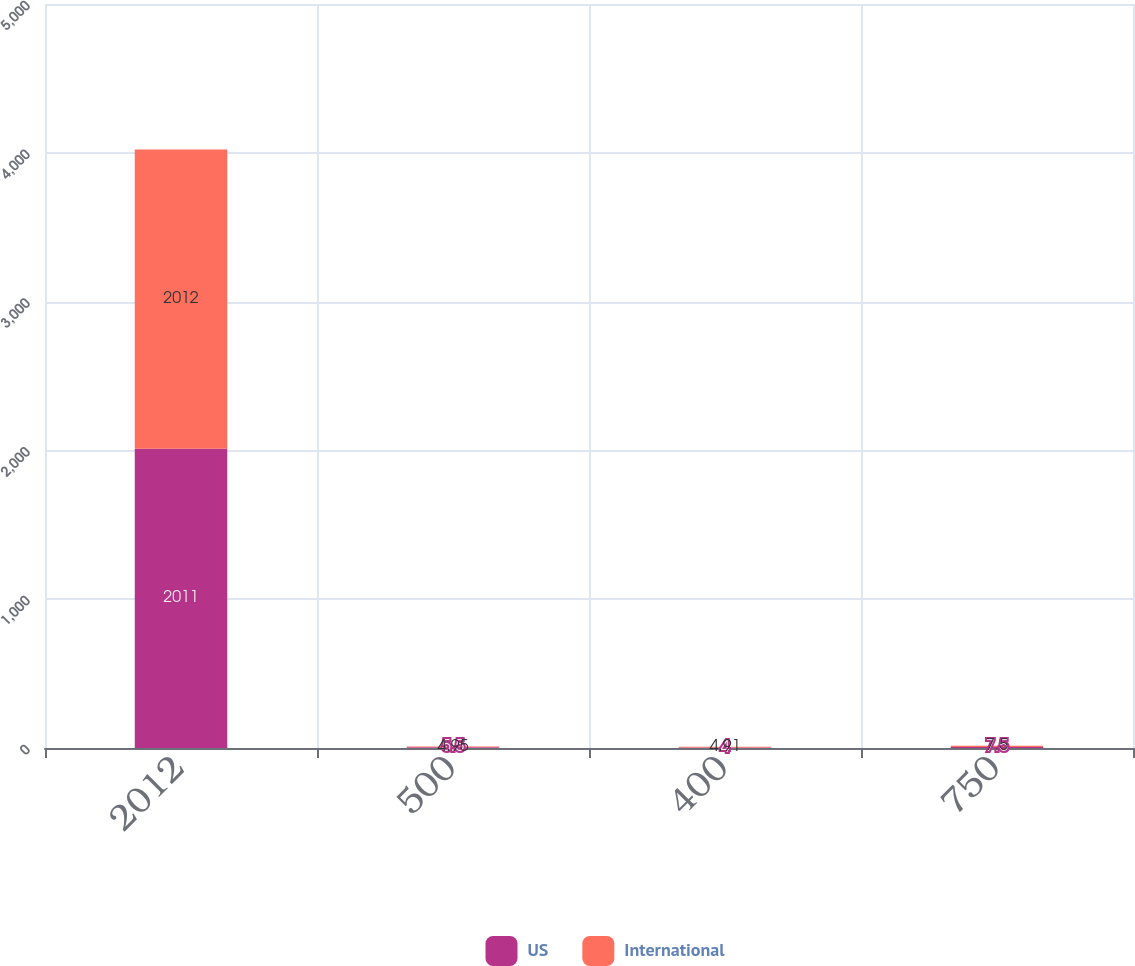Convert chart. <chart><loc_0><loc_0><loc_500><loc_500><stacked_bar_chart><ecel><fcel>2012<fcel>500<fcel>400<fcel>750<nl><fcel>US<fcel>2011<fcel>5.5<fcel>4<fcel>7.5<nl><fcel>International<fcel>2012<fcel>4.95<fcel>4.91<fcel>7.5<nl></chart> 